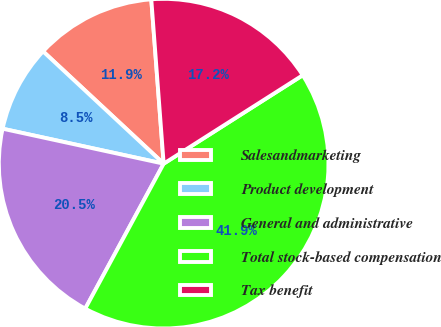Convert chart. <chart><loc_0><loc_0><loc_500><loc_500><pie_chart><fcel>Salesandmarketing<fcel>Product development<fcel>General and administrative<fcel>Total stock-based compensation<fcel>Tax benefit<nl><fcel>11.87%<fcel>8.53%<fcel>20.51%<fcel>41.91%<fcel>17.18%<nl></chart> 